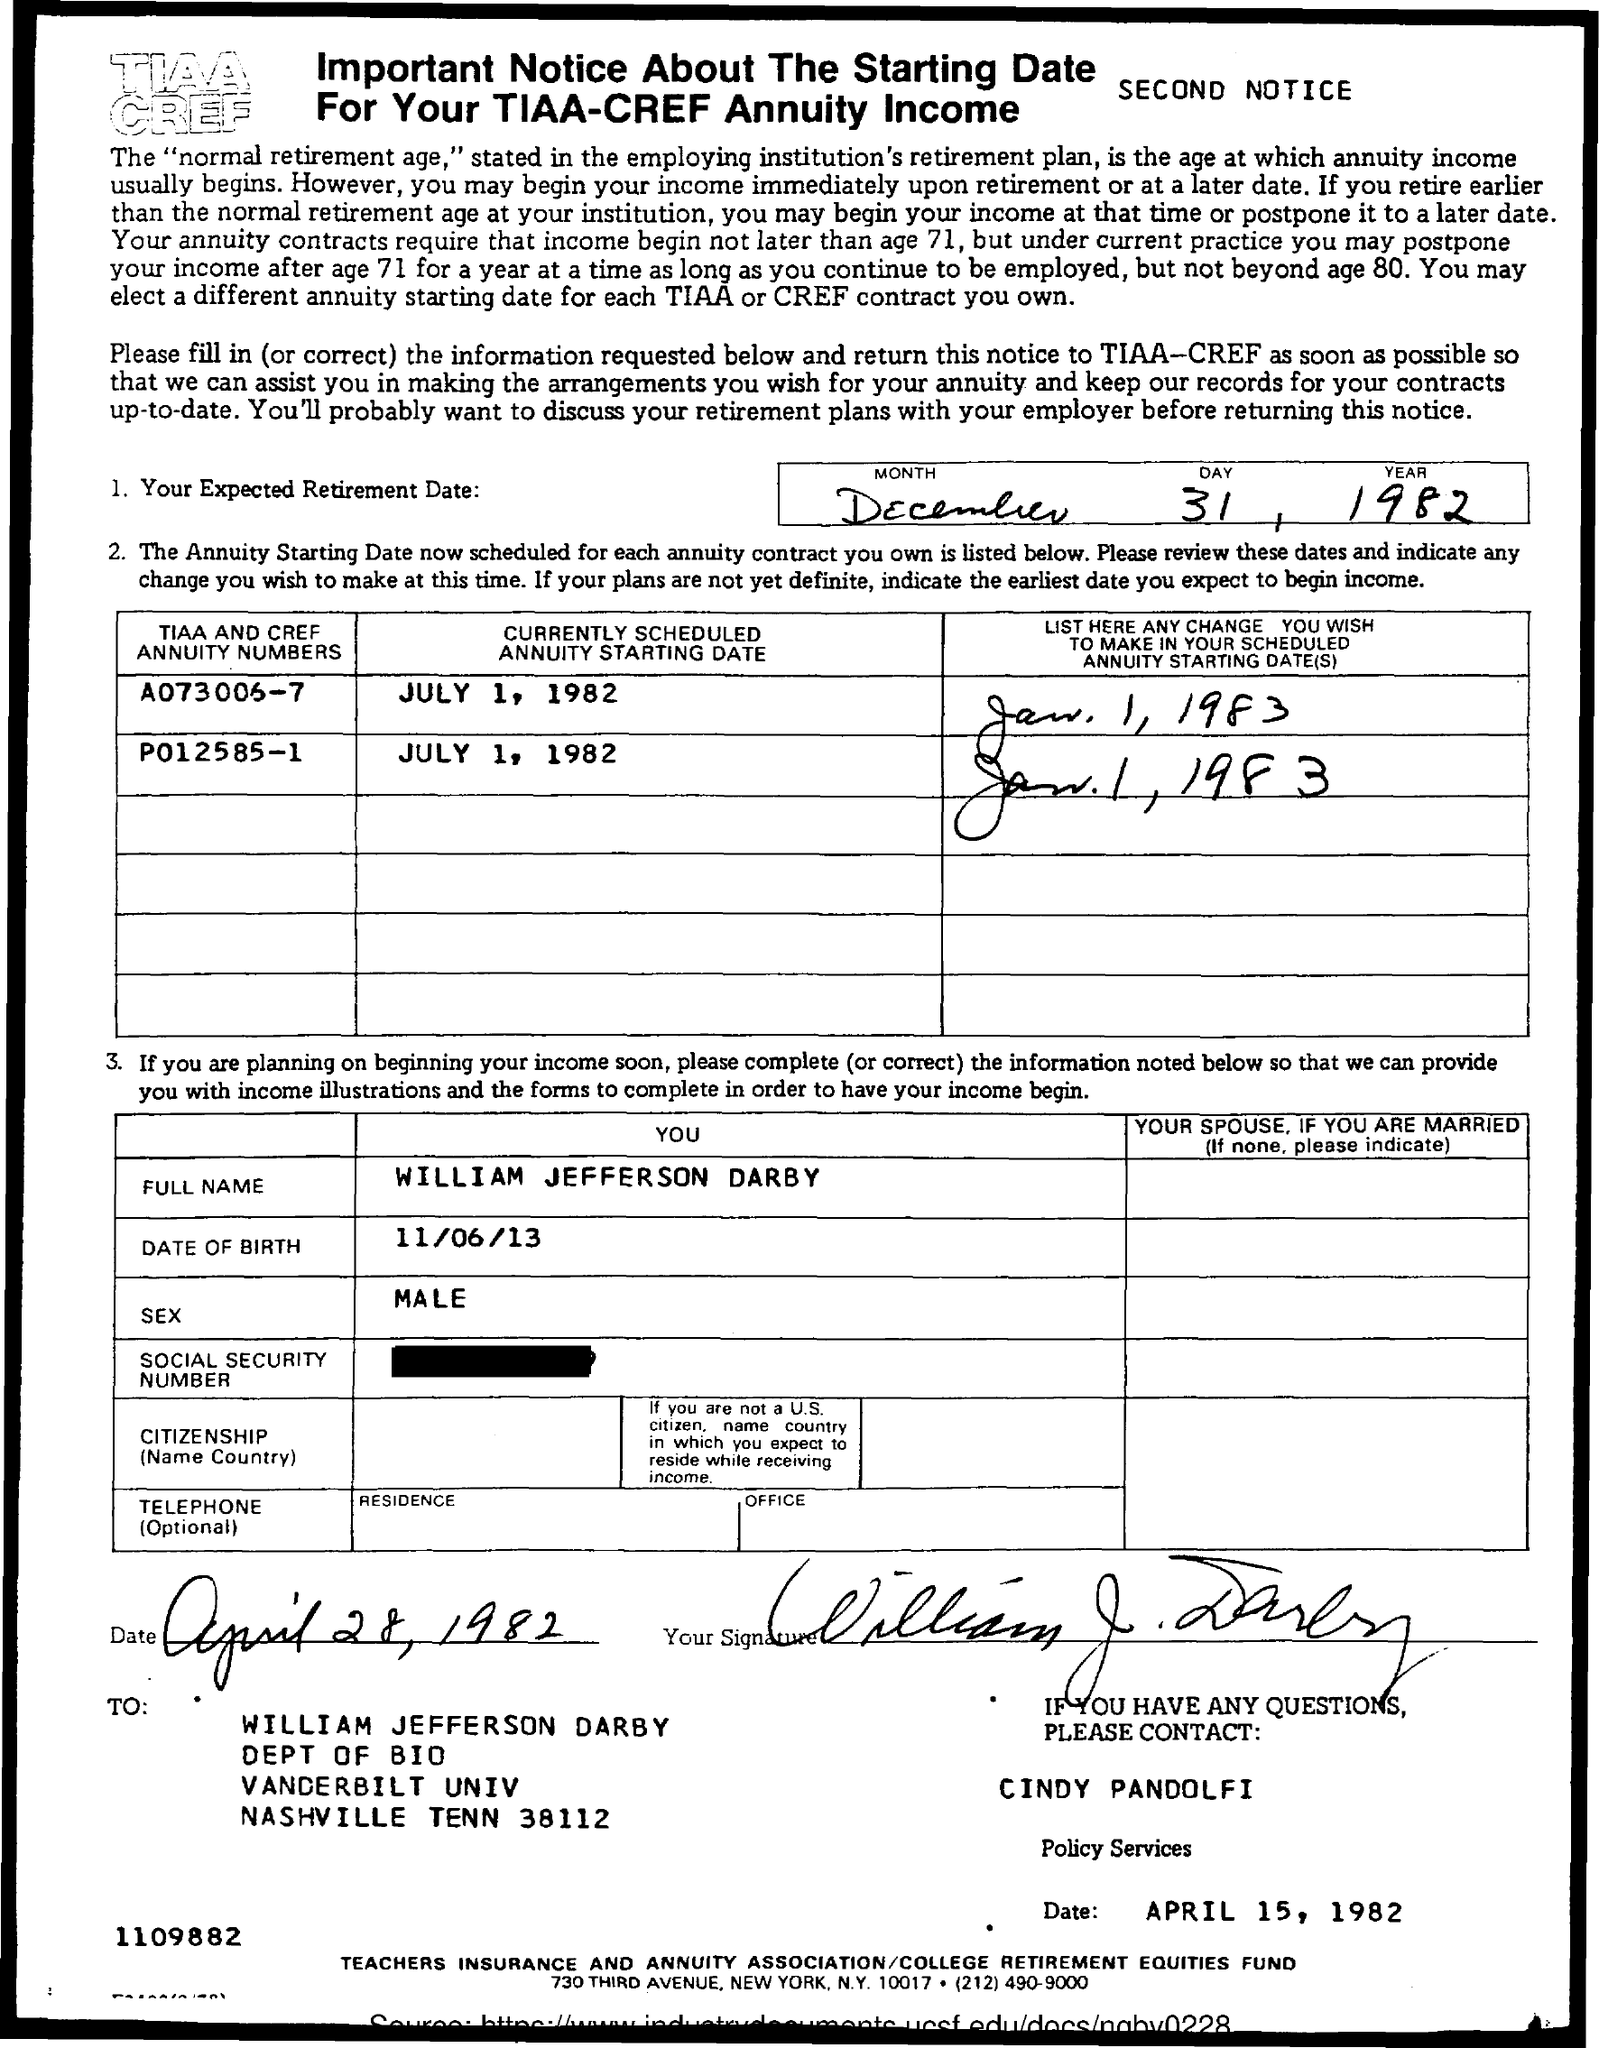What is your expected retirement date mentioned in the given form ?
Your answer should be compact. December 31, 1982. What is the full name mentioned ?
Ensure brevity in your answer.  William Jefferson Darby. What is the date of birth mentioned ?
Ensure brevity in your answer.  11/06/13. What is the sex mentioned ?
Make the answer very short. Male. What is the date mentioned at the bottom of the page ?
Make the answer very short. April 15, 1982. To whom the letter was sent ?
Your answer should be very brief. William jefferson darby. What is the name of the department mentioned ?
Provide a short and direct response. Dept of Bio. 